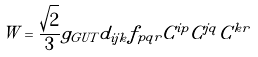Convert formula to latex. <formula><loc_0><loc_0><loc_500><loc_500>W = \frac { \sqrt { 2 } } { 3 } g _ { G U T } d _ { i j k } f _ { p q r } C ^ { i p } C ^ { j q } C ^ { k r }</formula> 